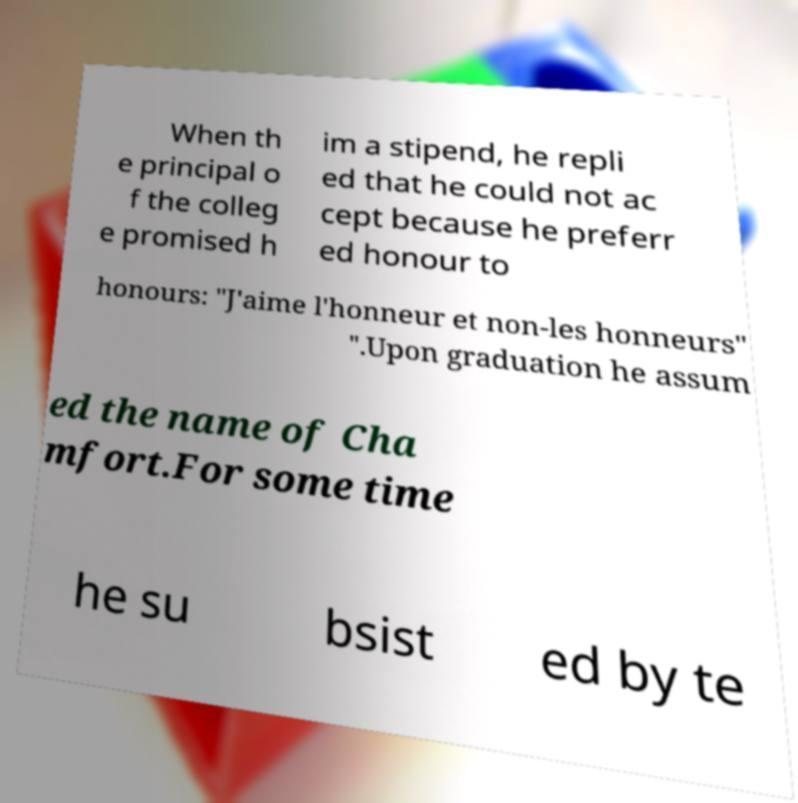There's text embedded in this image that I need extracted. Can you transcribe it verbatim? When th e principal o f the colleg e promised h im a stipend, he repli ed that he could not ac cept because he preferr ed honour to honours: "J'aime l'honneur et non-les honneurs" ".Upon graduation he assum ed the name of Cha mfort.For some time he su bsist ed by te 